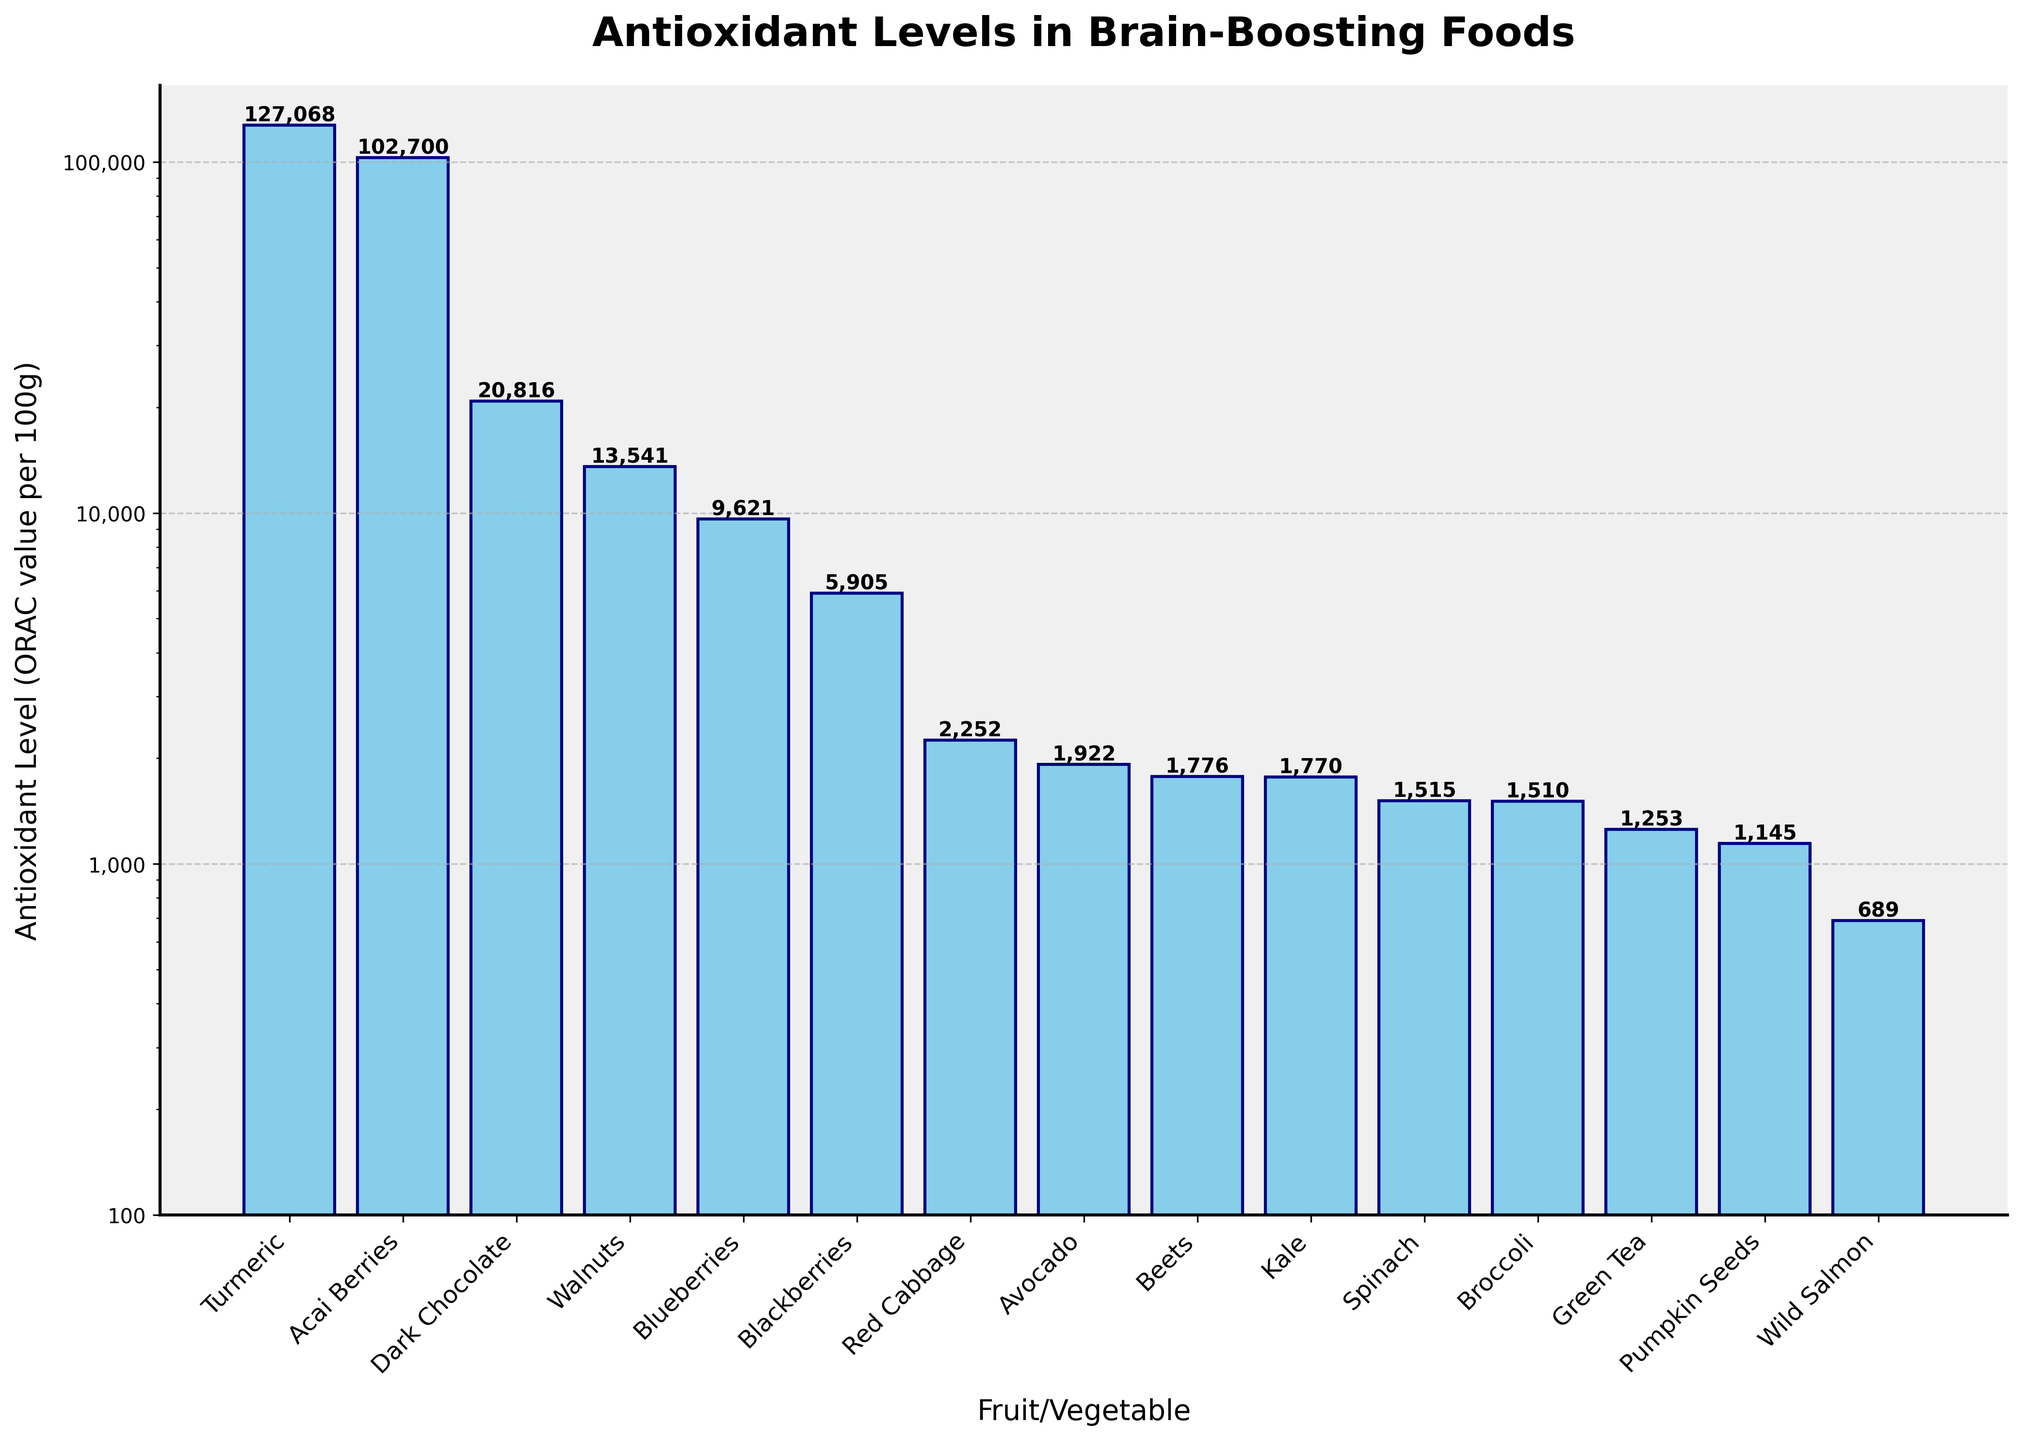Which food has the highest antioxidant level? The bar for Turmeric is the tallest, indicating it has the highest ORAC value.
Answer: Turmeric Which fruit or vegetable has a higher antioxidant level: Blueberries or Blackberries? By comparing the heights of the bars, Blueberries have a higher ORAC value than Blackberries.
Answer: Blueberries What's the total antioxidant level of Spinach and Broccoli combined? Add the ORAC values of Spinach (1515) and Broccoli (1510): 1515 + 1510 = 3025.
Answer: 3025 Which food category, fruits or vegetables, generally has higher antioxidant levels based on this chart? Visual inspection shows that fruits like Turmeric, Acai Berries, and Blueberries have higher ORAC values compared to most vegetables.
Answer: Fruits Which two foods have the most similar antioxidant levels and what are their values? By examining the lengths of the bars, Spinach (1515) and Broccoli (1510) have the most similar ORAC values.
Answer: Spinach and Broccoli, 1515 and 1510 How does the antioxidant level of Dark Chocolate compare to that of Walnuts? Dark Chocolate has a slightly higher ORAC value at 20816 compared to Walnuts' 13541.
Answer: Dark Chocolate is higher What's the difference in antioxidant levels between the highest and the lowest food item? Subtract the ORAC value of Wild Salmon (689) from Turmeric (127068): 127068 - 689 = 126379.
Answer: 126379 Which foods have antioxidant levels greater than 20000? The only bar taller than 20000 belongs to Dark Chocolate and Turmeric.
Answer: Dark Chocolate, Turmeric By what factor is the ORAC value of Acai Berries greater than that of Avocado? Divide the ORAC value of Acai Berries (102700) by Avocado (1922): 102700 / 1922 ≈ 53.45.
Answer: About 53.45 times What is the median antioxidant level of the foods listed in the chart? Ordering the ORAC values and finding the middle value: 1253, 1355, 1510, 1515, 1770, 1776, 1922, 2252, 5905, 9621, 13541, 20816, 102700, 127068. The median falls between 1770 and 1776; average is (1770 + 1776) / 2 = 1773.
Answer: 1773 